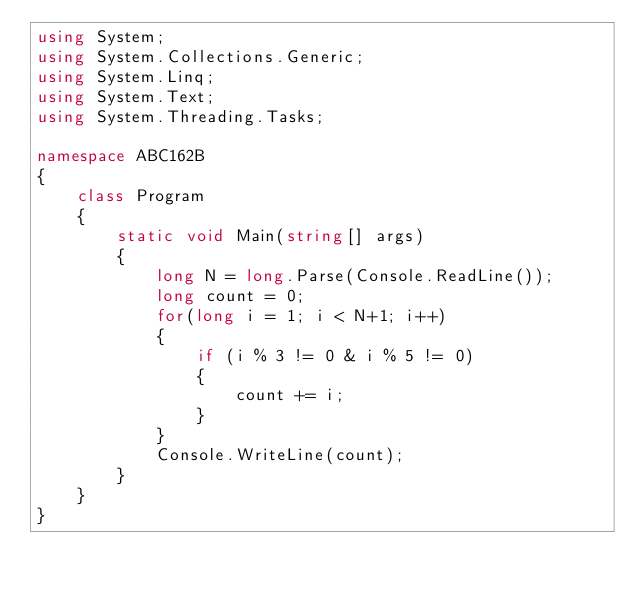<code> <loc_0><loc_0><loc_500><loc_500><_C#_>using System;
using System.Collections.Generic;
using System.Linq;
using System.Text;
using System.Threading.Tasks;

namespace ABC162B
{
    class Program
    {
        static void Main(string[] args)
        {
            long N = long.Parse(Console.ReadLine());
            long count = 0;
            for(long i = 1; i < N+1; i++)
            {
                if (i % 3 != 0 & i % 5 != 0)
                {
                    count += i;
                }
            }
            Console.WriteLine(count);
        }
    }
}
</code> 